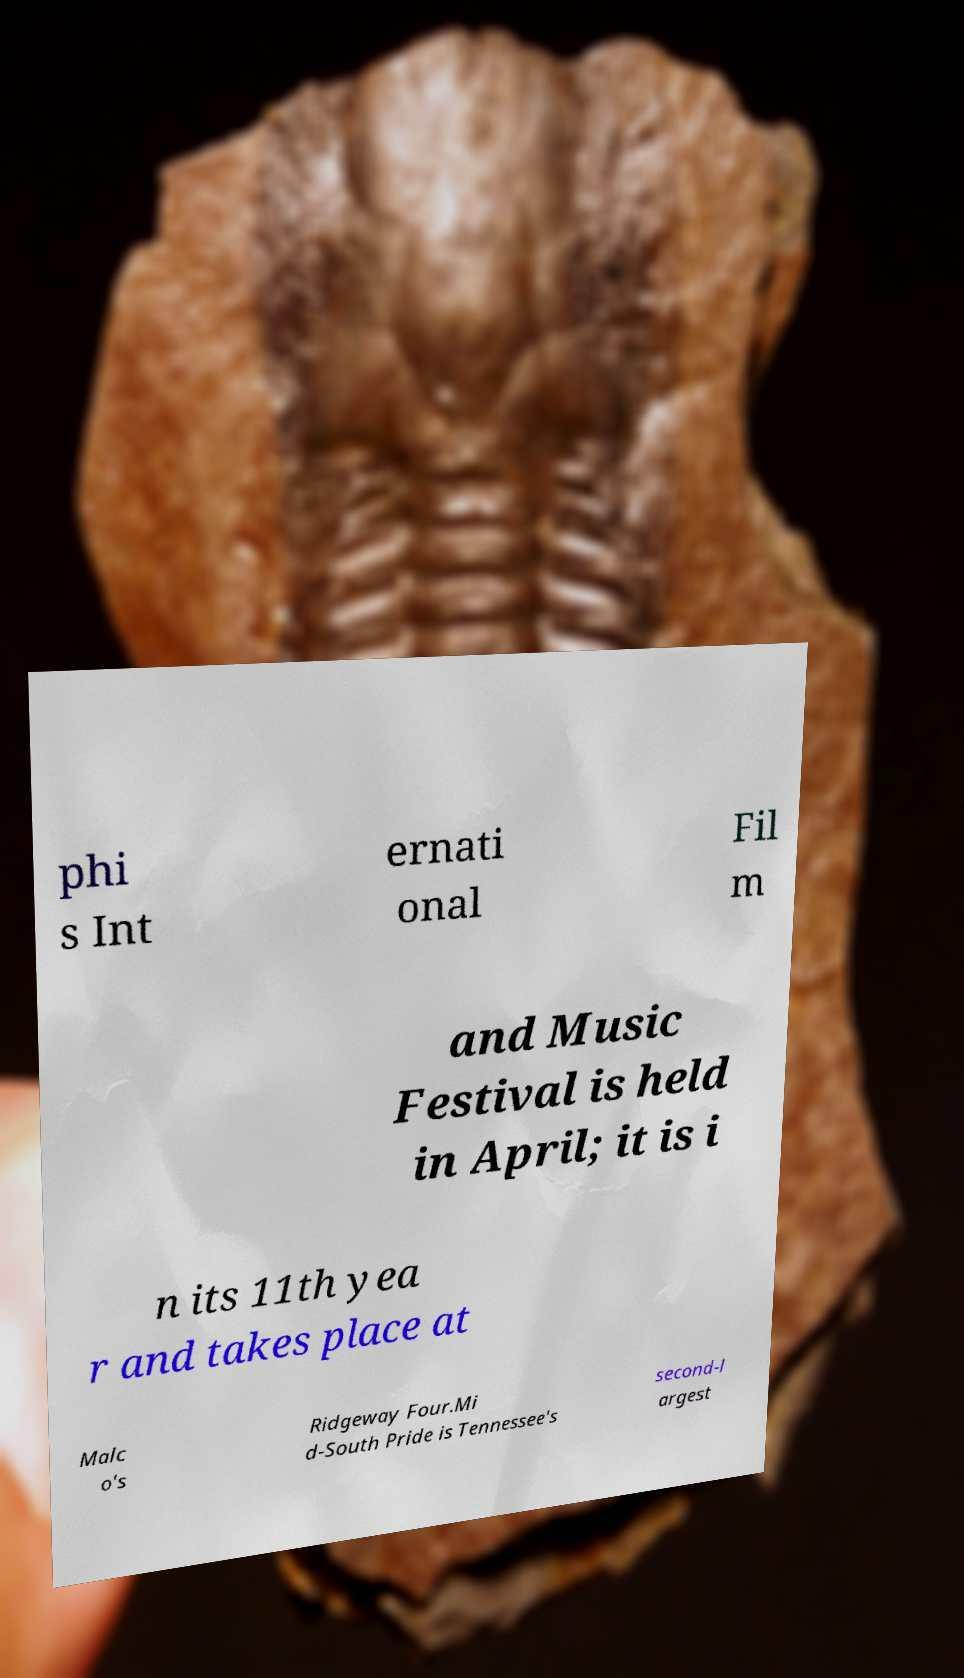Can you accurately transcribe the text from the provided image for me? phi s Int ernati onal Fil m and Music Festival is held in April; it is i n its 11th yea r and takes place at Malc o's Ridgeway Four.Mi d-South Pride is Tennessee's second-l argest 